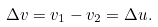<formula> <loc_0><loc_0><loc_500><loc_500>\Delta v = v _ { 1 } - v _ { 2 } = \Delta u .</formula> 